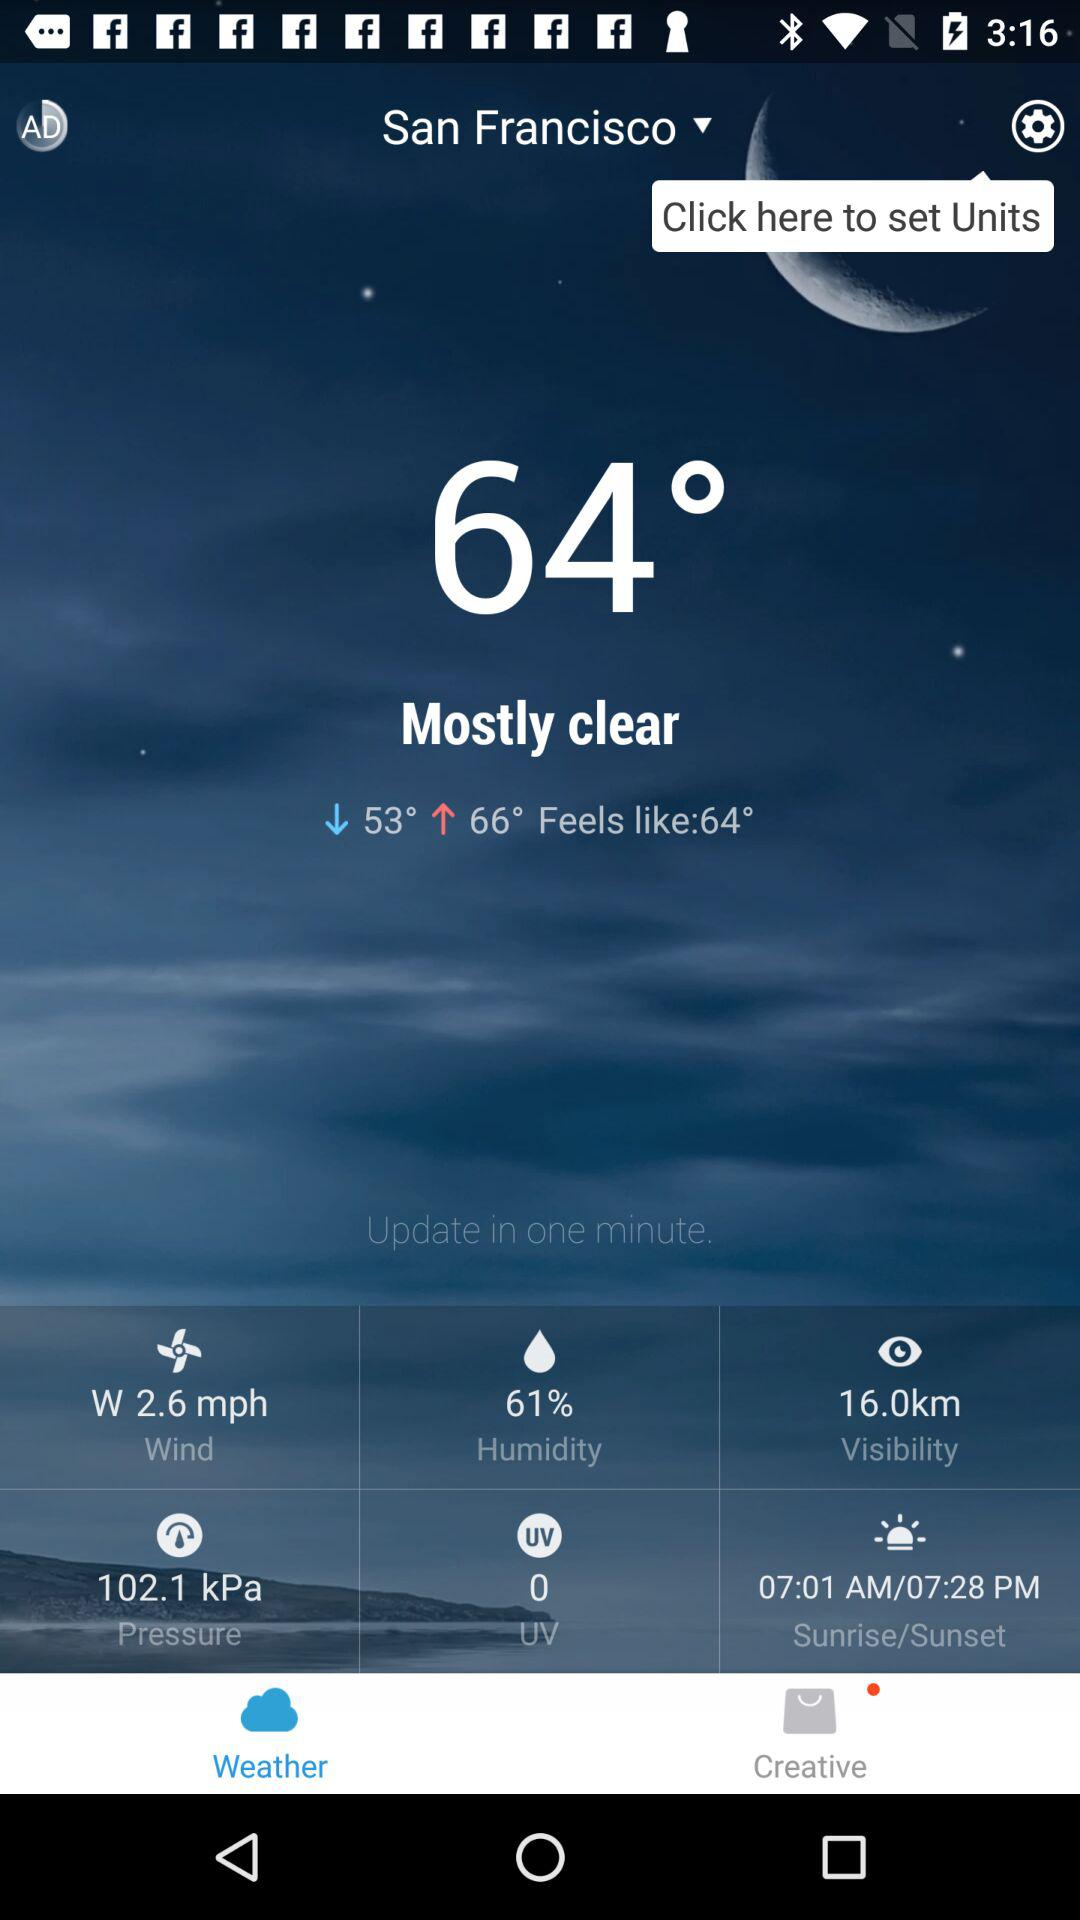What is the humidity in San Francisco?
Answer the question using a single word or phrase. 61% 